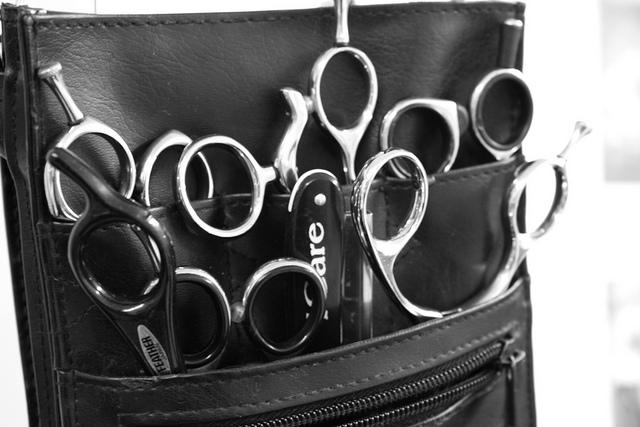Are they perfect circles?
Write a very short answer. No. Is the zipper open or closed?
Concise answer only. Open. How many circles are there?
Give a very brief answer. 11. 